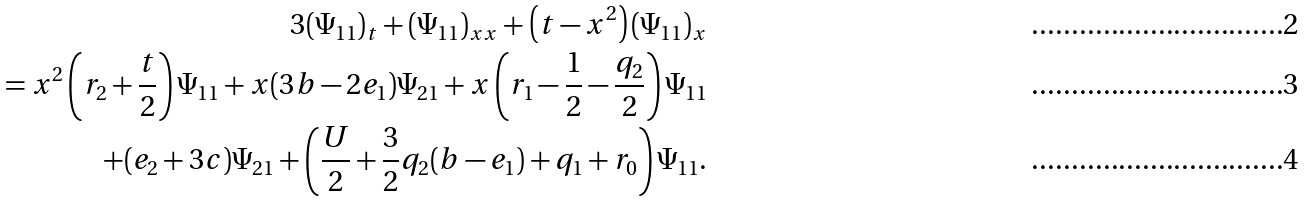Convert formula to latex. <formula><loc_0><loc_0><loc_500><loc_500>3 ( \Psi _ { 1 1 } ) _ { t } + ( \Psi _ { 1 1 } ) _ { x x } + \left ( t - x ^ { 2 } \right ) ( \Psi _ { 1 1 } ) _ { x } \\ = x ^ { 2 } \left ( r _ { 2 } + \frac { t } { 2 } \right ) \Psi _ { 1 1 } + x ( 3 b - 2 e _ { 1 } ) \Psi _ { 2 1 } + x \left ( r _ { 1 } - \frac { 1 } { 2 } - \frac { q _ { 2 } } { 2 } \right ) \Psi _ { 1 1 } \\ \quad + ( e _ { 2 } + 3 c ) \Psi _ { 2 1 } + \left ( \frac { U } { 2 } + \frac { 3 } { 2 } q _ { 2 } ( b - e _ { 1 } ) + q _ { 1 } + r _ { 0 } \right ) \Psi _ { 1 1 } .</formula> 